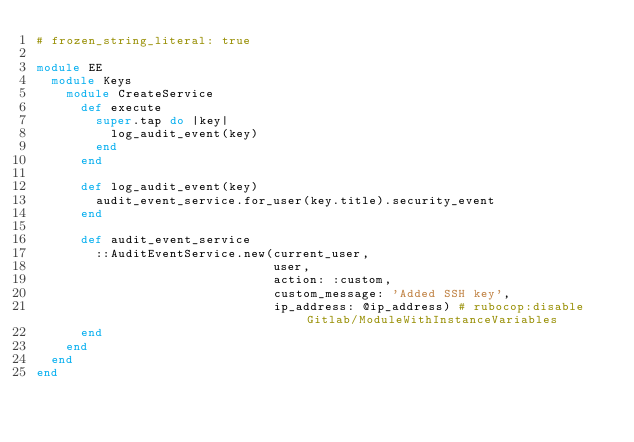<code> <loc_0><loc_0><loc_500><loc_500><_Ruby_># frozen_string_literal: true

module EE
  module Keys
    module CreateService
      def execute
        super.tap do |key|
          log_audit_event(key)
        end
      end

      def log_audit_event(key)
        audit_event_service.for_user(key.title).security_event
      end

      def audit_event_service
        ::AuditEventService.new(current_user,
                                user,
                                action: :custom,
                                custom_message: 'Added SSH key',
                                ip_address: @ip_address) # rubocop:disable Gitlab/ModuleWithInstanceVariables
      end
    end
  end
end
</code> 